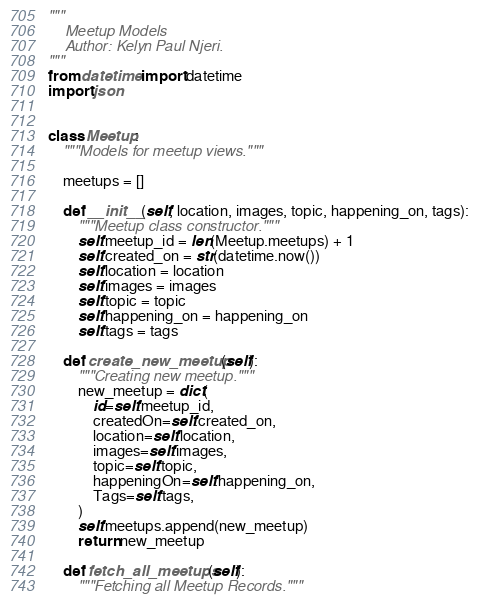<code> <loc_0><loc_0><loc_500><loc_500><_Python_>"""
    Meetup Models
    Author: Kelyn Paul Njeri.
"""
from datetime import datetime
import json


class Meetup:
    """Models for meetup views."""

    meetups = []

    def __init__(self, location, images, topic, happening_on, tags):
        """Meetup class constructor."""
        self.meetup_id = len(Meetup.meetups) + 1
        self.created_on = str(datetime.now())
        self.location = location
        self.images = images
        self.topic = topic
        self.happening_on = happening_on
        self.tags = tags

    def create_new_meetup(self):
        """Creating new meetup."""
        new_meetup = dict(
            id=self.meetup_id,
            createdOn=self.created_on,
            location=self.location,
            images=self.images,
            topic=self.topic,
            happeningOn=self.happening_on,
            Tags=self.tags,
        )
        self.meetups.append(new_meetup)
        return new_meetup

    def fetch_all_meetups(self):
        """Fetching all Meetup Records."""</code> 